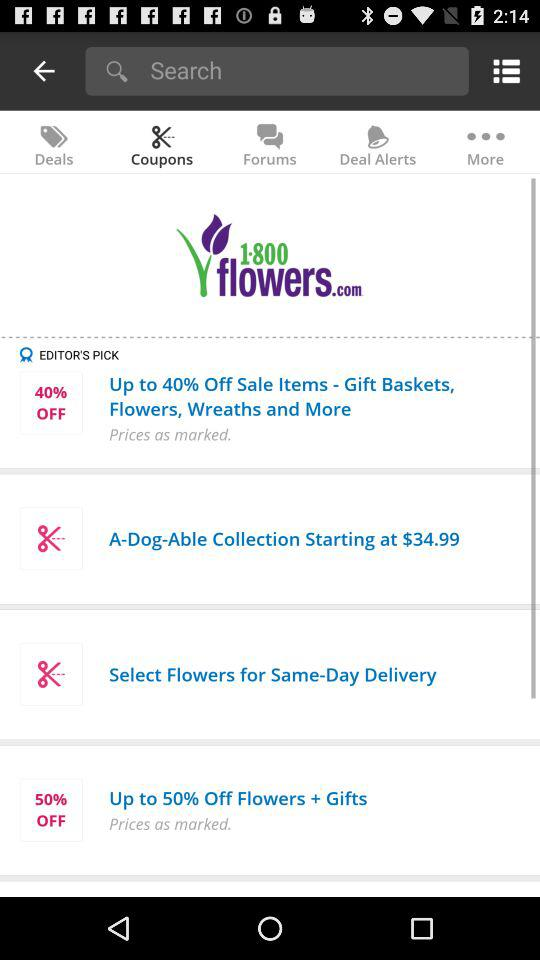What is the starting price of "A-Dog-Able Collection"? The starting price is $34.99. 